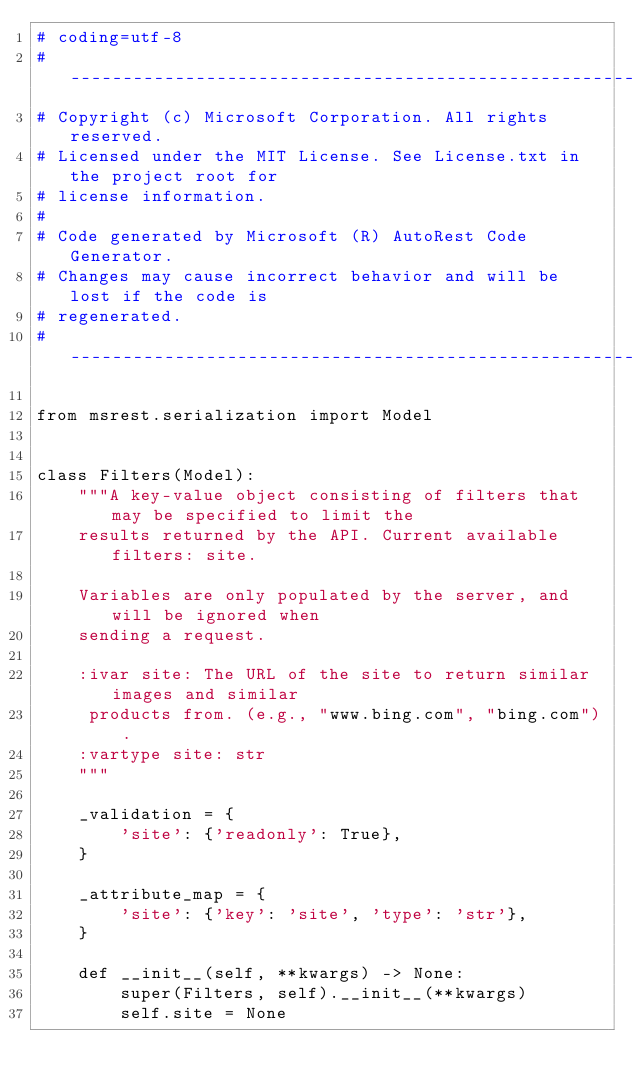<code> <loc_0><loc_0><loc_500><loc_500><_Python_># coding=utf-8
# --------------------------------------------------------------------------
# Copyright (c) Microsoft Corporation. All rights reserved.
# Licensed under the MIT License. See License.txt in the project root for
# license information.
#
# Code generated by Microsoft (R) AutoRest Code Generator.
# Changes may cause incorrect behavior and will be lost if the code is
# regenerated.
# --------------------------------------------------------------------------

from msrest.serialization import Model


class Filters(Model):
    """A key-value object consisting of filters that may be specified to limit the
    results returned by the API. Current available filters: site.

    Variables are only populated by the server, and will be ignored when
    sending a request.

    :ivar site: The URL of the site to return similar images and similar
     products from. (e.g., "www.bing.com", "bing.com").
    :vartype site: str
    """

    _validation = {
        'site': {'readonly': True},
    }

    _attribute_map = {
        'site': {'key': 'site', 'type': 'str'},
    }

    def __init__(self, **kwargs) -> None:
        super(Filters, self).__init__(**kwargs)
        self.site = None
</code> 